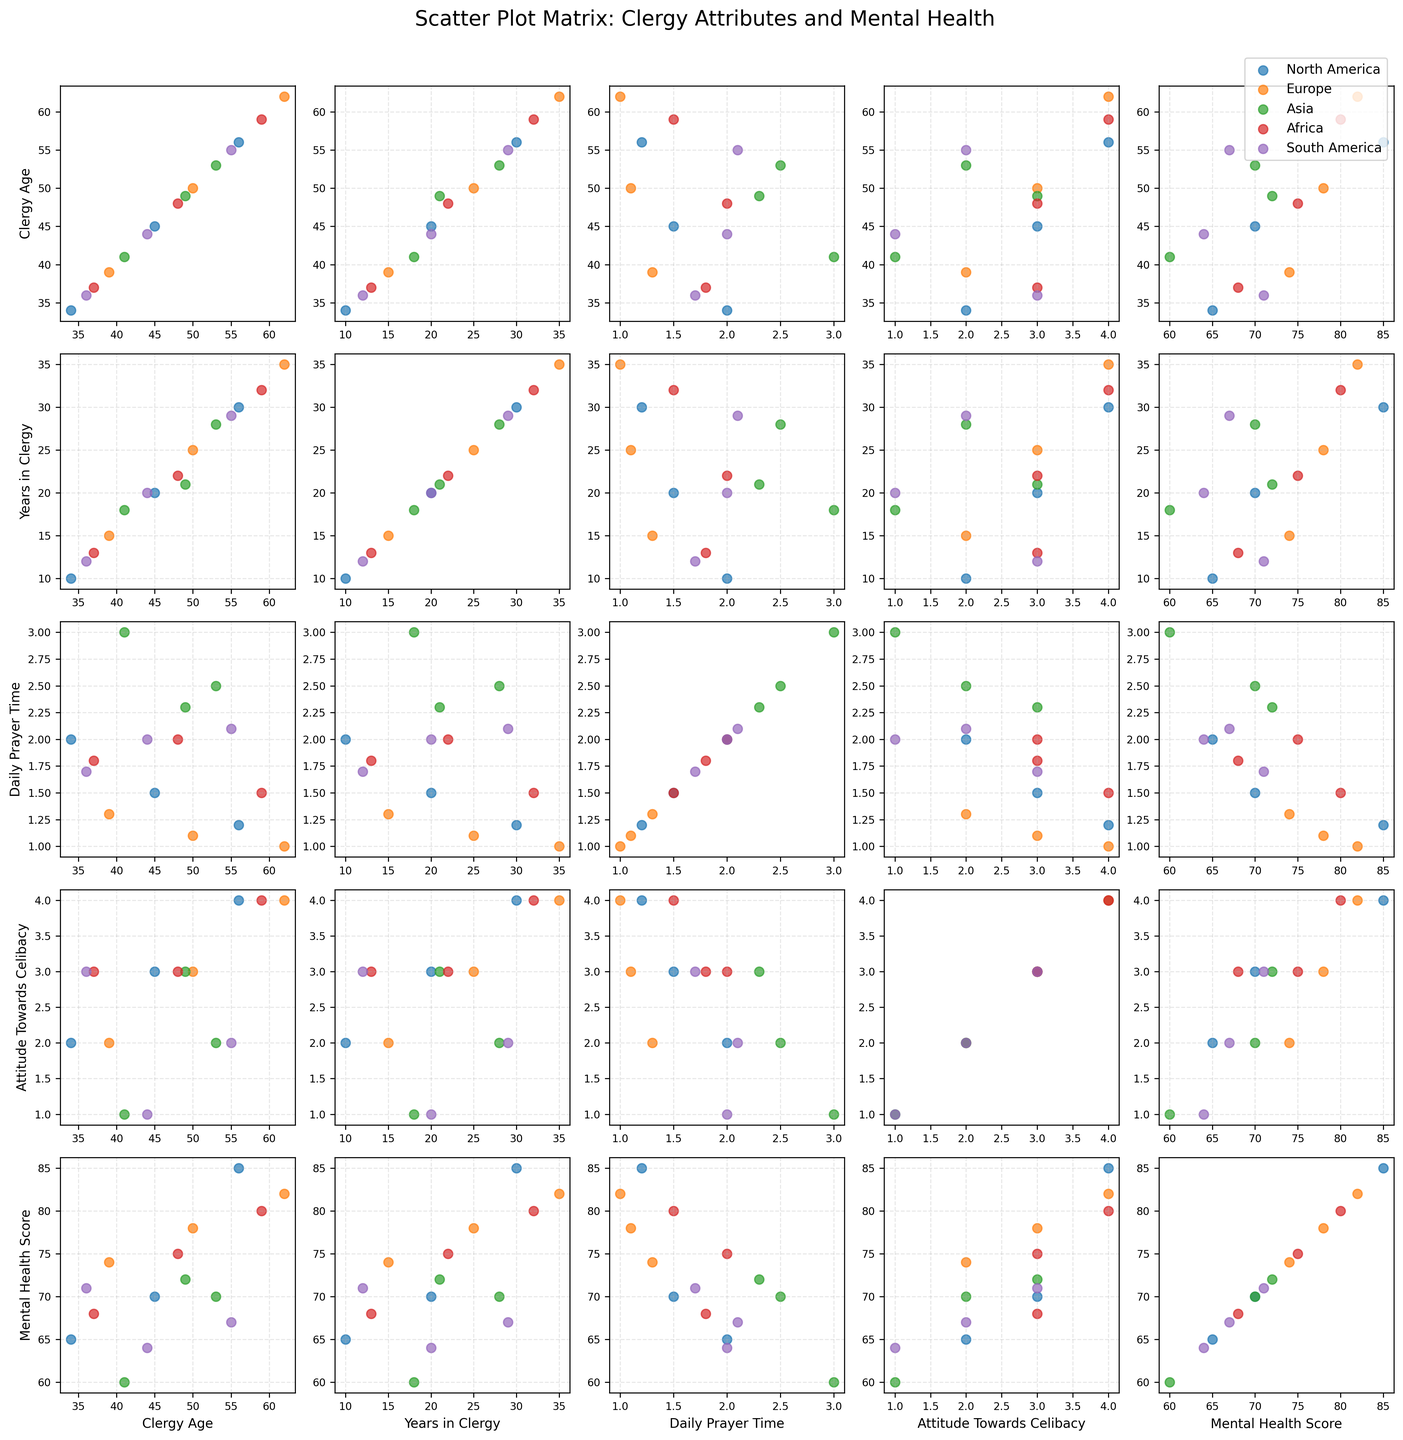what is the title of the scatter plot matrix? The title of the scatter plot matrix can be found at the top of the figure and it is prominently displayed.
Answer: Scatter Plot Matrix: Clergy Attributes and Mental Health How many continents are represented in the scatter plot matrix? The continents are represented by different colors in the plot. By counting the unique colors in the legend, we can determine the number of continents.
Answer: Five What color represents Asia in the scatter plot matrix? By referring to the legend in the upper right corner, we can identify which color corresponds to Asia.
Answer: Green Which continent has the clergy member with the highest mental health score? By identifying the highest point on the "Mental Health Score" axis and checking its corresponding color, we can determine which continent it belongs to.
Answer: North America Is there a clear trend between 'Years in Clergy' and 'Mental Health Score'? By examining the scatter plots where 'Years in Clergy' is plotted against 'Mental Health Score' for the different continents, we can observe if there is an upward or downward trend.
Answer: No clear trend Which age group (youngest or oldest) spends more time in daily prayer on average? Calculate the average daily prayer time for the youngest and oldest clergy members by referring to the “Daily Prayer Time” and “Clergy Age” axes and their corresponding points.
Answer: Oldest Do clergy members from Africa have a more positive attitude towards celibacy compared to clergy from South America? Compare the values on the "Attitude Towards Celibacy" axis for clergy members from Africa and South America.
Answer: Yes Which continent shows the most variation in the 'Daily Prayer Time' across different clergy ages? Assess the spread of points along the vertical axis in the plots where 'Daily Prayer Time' is on one axis and 'Clergy Age' is on the other axis for each continent.
Answer: Asia Does a higher 'Daily Prayer Time' always correlate with a higher 'Mental Health Score'? Examine the scatter plots where ‘Daily Prayer Time’ is plotted against ‘Mental Health Score’ and observe if higher prayer time points correspond to higher mental health scores.
Answer: No 